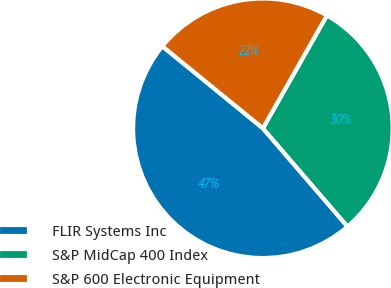Convert chart. <chart><loc_0><loc_0><loc_500><loc_500><pie_chart><fcel>FLIR Systems Inc<fcel>S&P MidCap 400 Index<fcel>S&P 600 Electronic Equipment<nl><fcel>47.21%<fcel>30.47%<fcel>22.32%<nl></chart> 